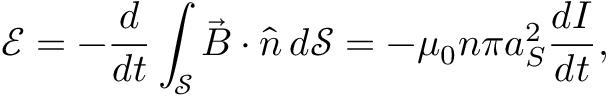Convert formula to latex. <formula><loc_0><loc_0><loc_500><loc_500>\mathcal { E } = - \frac { d } { d t } \int _ { \mathcal { S } } \vec { B } \cdot \hat { n } \, d \mathcal { S } = - \mu _ { 0 } n \pi a _ { S } ^ { 2 } \frac { d I } { d t } ,</formula> 